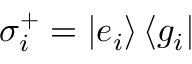<formula> <loc_0><loc_0><loc_500><loc_500>\sigma _ { i } ^ { + } = \left | e _ { i } \right \rangle \left \langle g _ { i } \right |</formula> 